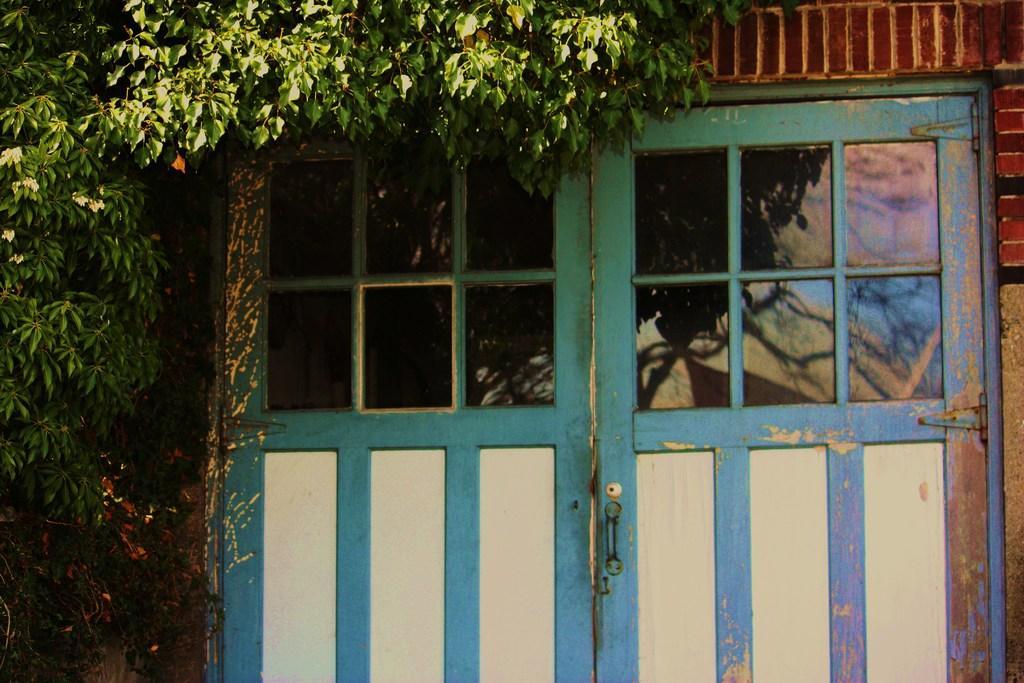Please provide a concise description of this image. On the left side, there is a tree which is having green color leaves near a building. Which is having doors which are having glass. 